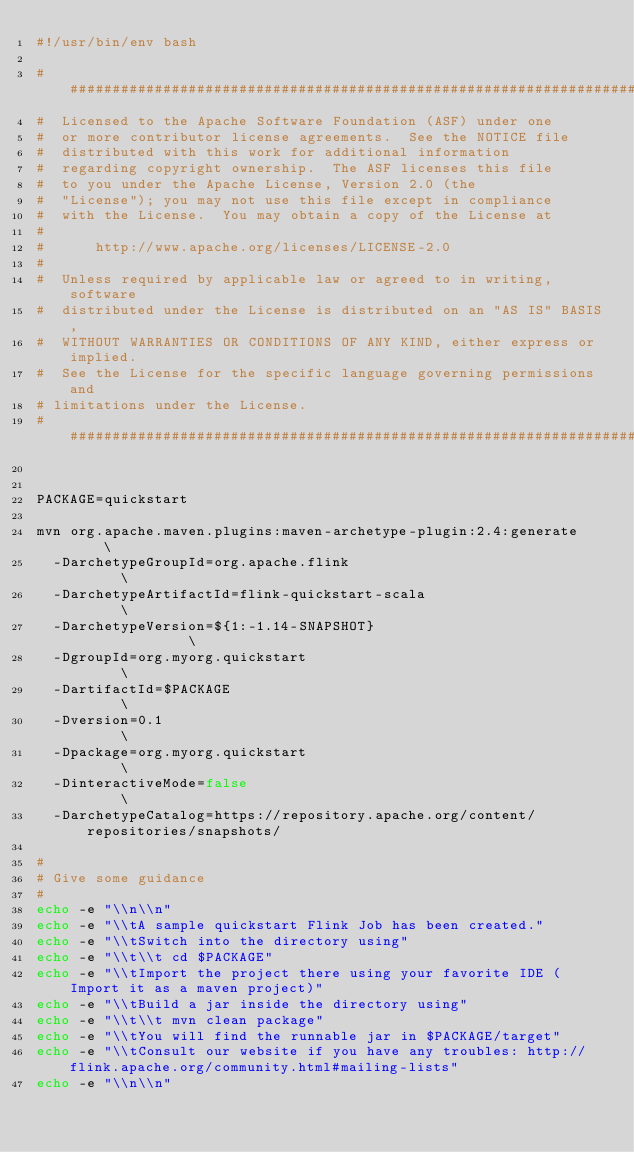Convert code to text. <code><loc_0><loc_0><loc_500><loc_500><_Bash_>#!/usr/bin/env bash

################################################################################
#  Licensed to the Apache Software Foundation (ASF) under one
#  or more contributor license agreements.  See the NOTICE file
#  distributed with this work for additional information
#  regarding copyright ownership.  The ASF licenses this file
#  to you under the Apache License, Version 2.0 (the
#  "License"); you may not use this file except in compliance
#  with the License.  You may obtain a copy of the License at
#
#      http://www.apache.org/licenses/LICENSE-2.0
#
#  Unless required by applicable law or agreed to in writing, software
#  distributed under the License is distributed on an "AS IS" BASIS,
#  WITHOUT WARRANTIES OR CONDITIONS OF ANY KIND, either express or implied.
#  See the License for the specific language governing permissions and
# limitations under the License.
################################################################################


PACKAGE=quickstart

mvn org.apache.maven.plugins:maven-archetype-plugin:2.4:generate	\
  -DarchetypeGroupId=org.apache.flink 								\
  -DarchetypeArtifactId=flink-quickstart-scala						\
  -DarchetypeVersion=${1:-1.14-SNAPSHOT}									\
  -DgroupId=org.myorg.quickstart									\
  -DartifactId=$PACKAGE												\
  -Dversion=0.1														\
  -Dpackage=org.myorg.quickstart									\
  -DinteractiveMode=false											\
  -DarchetypeCatalog=https://repository.apache.org/content/repositories/snapshots/

#
# Give some guidance
#
echo -e "\\n\\n"
echo -e "\\tA sample quickstart Flink Job has been created."
echo -e "\\tSwitch into the directory using"
echo -e "\\t\\t cd $PACKAGE"
echo -e "\\tImport the project there using your favorite IDE (Import it as a maven project)"
echo -e "\\tBuild a jar inside the directory using"
echo -e "\\t\\t mvn clean package"
echo -e "\\tYou will find the runnable jar in $PACKAGE/target"
echo -e "\\tConsult our website if you have any troubles: http://flink.apache.org/community.html#mailing-lists"
echo -e "\\n\\n"
</code> 